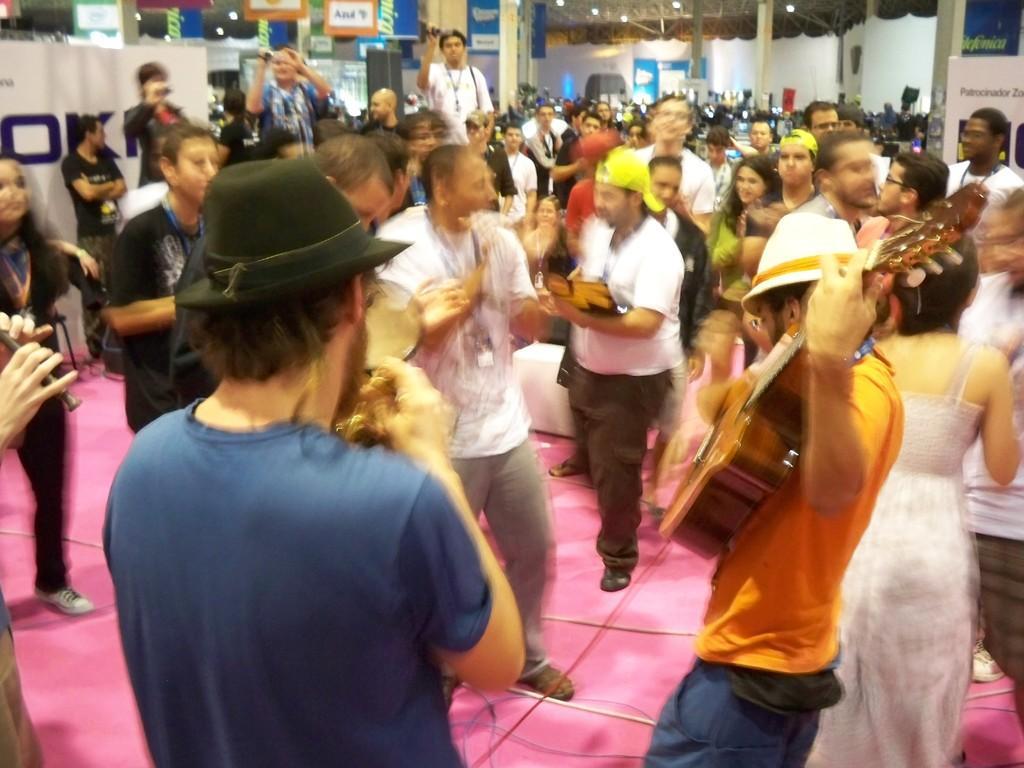Could you give a brief overview of what you see in this image? In this picture we can see a group of people standing on the floor, guitar, caps, cameras, posters, pillars, lights and some objects and in the background we can see the wall. 